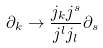Convert formula to latex. <formula><loc_0><loc_0><loc_500><loc_500>\partial _ { k } \rightarrow \frac { j _ { k } j ^ { s } } { j ^ { l } j _ { l } } \partial _ { s }</formula> 